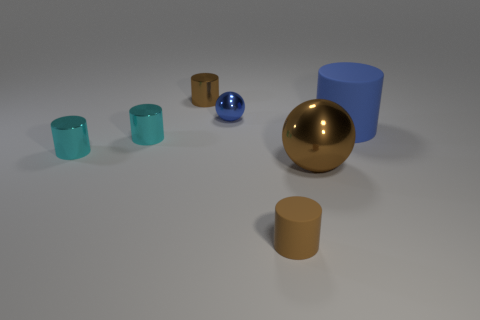What shape is the blue shiny thing that is the same size as the brown matte cylinder?
Keep it short and to the point. Sphere. What number of other things are the same color as the small sphere?
Ensure brevity in your answer.  1. What is the color of the small cylinder behind the blue sphere?
Keep it short and to the point. Brown. What number of other things are there of the same material as the large blue cylinder
Make the answer very short. 1. Is the number of brown cylinders behind the small blue metal sphere greater than the number of large blue matte cylinders behind the tiny brown metal thing?
Your answer should be very brief. Yes. There is a tiny blue shiny sphere; how many large things are to the right of it?
Ensure brevity in your answer.  2. Are the big sphere and the blue object on the right side of the small blue metallic sphere made of the same material?
Your answer should be very brief. No. Are the small sphere and the big brown sphere made of the same material?
Your response must be concise. Yes. There is a small brown cylinder that is left of the blue metal sphere; are there any blue things right of it?
Make the answer very short. Yes. What number of objects are both behind the large brown ball and right of the small blue object?
Give a very brief answer. 1. 